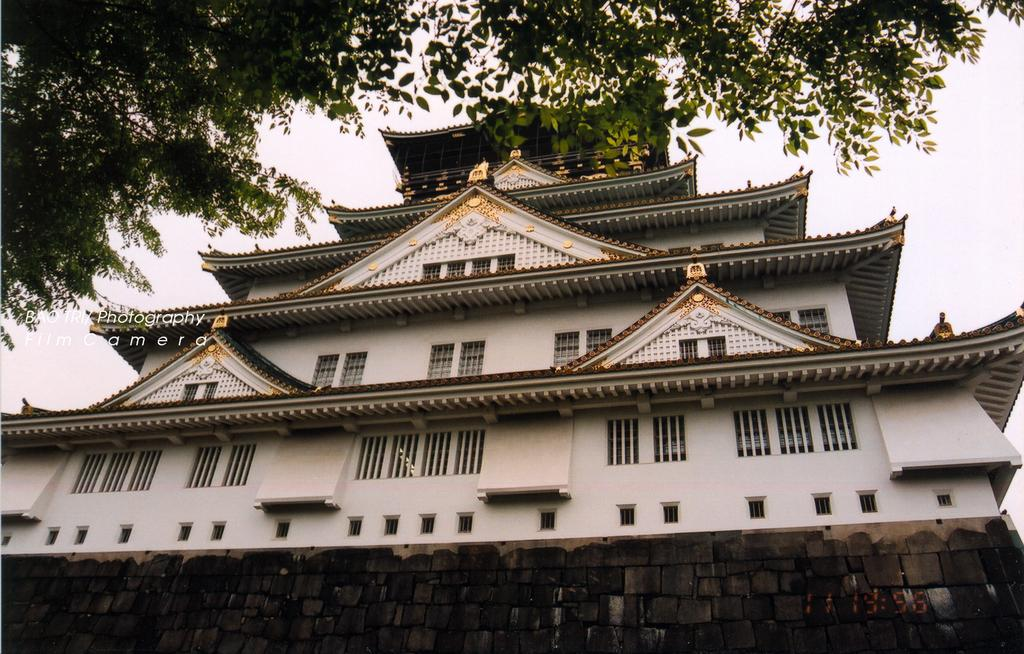What is the main subject of the image? The main subject of the image is a building. What features can be observed on the building? The building has windows and walls. What is present on the left side of the image? There is text on the left side of the image. What can be seen at the top of the image? A tree and the sky are visible at the top of the image. What type of force can be seen pushing the stream in the image? There is no stream or force present in the image. On which side of the building is the entrance located? The provided facts do not mention the location of the entrance, so it cannot be determined from the image. 